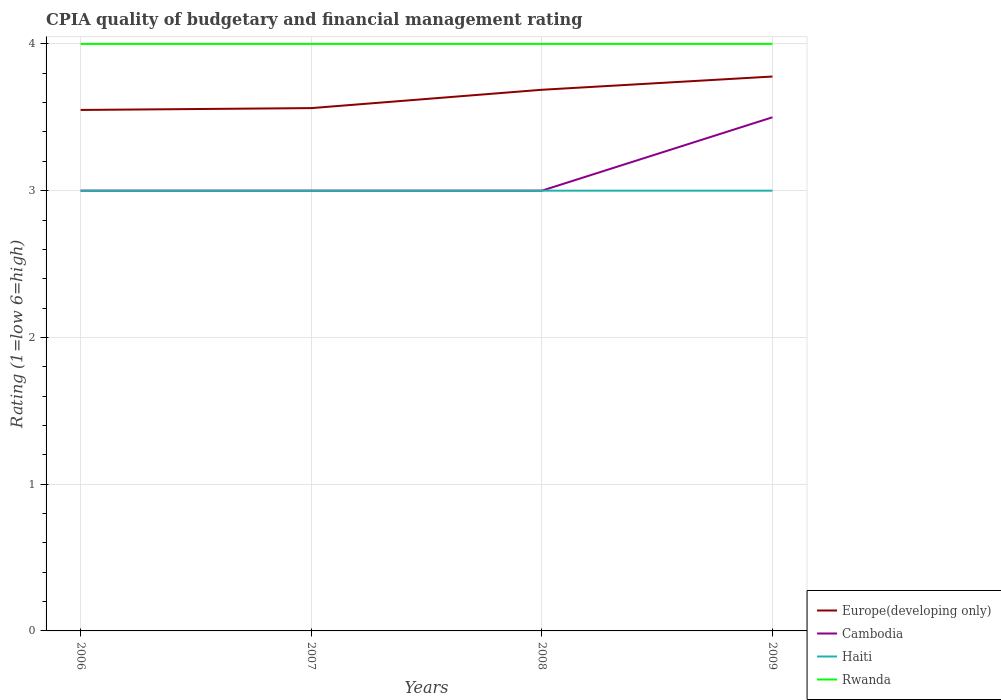Does the line corresponding to Rwanda intersect with the line corresponding to Cambodia?
Your answer should be compact. No. Is the number of lines equal to the number of legend labels?
Your answer should be compact. Yes. What is the total CPIA rating in Europe(developing only) in the graph?
Your answer should be compact. -0.01. What is the difference between the highest and the second highest CPIA rating in Cambodia?
Give a very brief answer. 0.5. What is the difference between the highest and the lowest CPIA rating in Haiti?
Provide a short and direct response. 0. What is the difference between two consecutive major ticks on the Y-axis?
Make the answer very short. 1. Does the graph contain any zero values?
Make the answer very short. No. Does the graph contain grids?
Provide a short and direct response. Yes. How many legend labels are there?
Your answer should be very brief. 4. How are the legend labels stacked?
Provide a succinct answer. Vertical. What is the title of the graph?
Give a very brief answer. CPIA quality of budgetary and financial management rating. What is the label or title of the X-axis?
Provide a succinct answer. Years. What is the Rating (1=low 6=high) of Europe(developing only) in 2006?
Your answer should be very brief. 3.55. What is the Rating (1=low 6=high) of Haiti in 2006?
Your response must be concise. 3. What is the Rating (1=low 6=high) in Rwanda in 2006?
Offer a very short reply. 4. What is the Rating (1=low 6=high) of Europe(developing only) in 2007?
Make the answer very short. 3.56. What is the Rating (1=low 6=high) in Cambodia in 2007?
Your answer should be compact. 3. What is the Rating (1=low 6=high) in Haiti in 2007?
Your answer should be compact. 3. What is the Rating (1=low 6=high) of Europe(developing only) in 2008?
Offer a very short reply. 3.69. What is the Rating (1=low 6=high) in Europe(developing only) in 2009?
Give a very brief answer. 3.78. What is the Rating (1=low 6=high) of Cambodia in 2009?
Your answer should be compact. 3.5. What is the Rating (1=low 6=high) of Haiti in 2009?
Your response must be concise. 3. Across all years, what is the maximum Rating (1=low 6=high) in Europe(developing only)?
Offer a very short reply. 3.78. Across all years, what is the maximum Rating (1=low 6=high) of Rwanda?
Offer a terse response. 4. Across all years, what is the minimum Rating (1=low 6=high) in Europe(developing only)?
Provide a short and direct response. 3.55. What is the total Rating (1=low 6=high) of Europe(developing only) in the graph?
Your response must be concise. 14.58. What is the total Rating (1=low 6=high) of Cambodia in the graph?
Offer a terse response. 12.5. What is the total Rating (1=low 6=high) in Rwanda in the graph?
Keep it short and to the point. 16. What is the difference between the Rating (1=low 6=high) in Europe(developing only) in 2006 and that in 2007?
Your answer should be very brief. -0.01. What is the difference between the Rating (1=low 6=high) in Rwanda in 2006 and that in 2007?
Ensure brevity in your answer.  0. What is the difference between the Rating (1=low 6=high) of Europe(developing only) in 2006 and that in 2008?
Keep it short and to the point. -0.14. What is the difference between the Rating (1=low 6=high) in Cambodia in 2006 and that in 2008?
Offer a very short reply. 0. What is the difference between the Rating (1=low 6=high) of Rwanda in 2006 and that in 2008?
Provide a short and direct response. 0. What is the difference between the Rating (1=low 6=high) of Europe(developing only) in 2006 and that in 2009?
Keep it short and to the point. -0.23. What is the difference between the Rating (1=low 6=high) in Rwanda in 2006 and that in 2009?
Your answer should be compact. 0. What is the difference between the Rating (1=low 6=high) of Europe(developing only) in 2007 and that in 2008?
Make the answer very short. -0.12. What is the difference between the Rating (1=low 6=high) of Haiti in 2007 and that in 2008?
Provide a succinct answer. 0. What is the difference between the Rating (1=low 6=high) of Rwanda in 2007 and that in 2008?
Your response must be concise. 0. What is the difference between the Rating (1=low 6=high) in Europe(developing only) in 2007 and that in 2009?
Offer a terse response. -0.22. What is the difference between the Rating (1=low 6=high) of Haiti in 2007 and that in 2009?
Ensure brevity in your answer.  0. What is the difference between the Rating (1=low 6=high) in Europe(developing only) in 2008 and that in 2009?
Offer a terse response. -0.09. What is the difference between the Rating (1=low 6=high) in Cambodia in 2008 and that in 2009?
Your answer should be compact. -0.5. What is the difference between the Rating (1=low 6=high) in Rwanda in 2008 and that in 2009?
Your response must be concise. 0. What is the difference between the Rating (1=low 6=high) of Europe(developing only) in 2006 and the Rating (1=low 6=high) of Cambodia in 2007?
Your response must be concise. 0.55. What is the difference between the Rating (1=low 6=high) of Europe(developing only) in 2006 and the Rating (1=low 6=high) of Haiti in 2007?
Give a very brief answer. 0.55. What is the difference between the Rating (1=low 6=high) of Europe(developing only) in 2006 and the Rating (1=low 6=high) of Rwanda in 2007?
Your answer should be very brief. -0.45. What is the difference between the Rating (1=low 6=high) in Cambodia in 2006 and the Rating (1=low 6=high) in Haiti in 2007?
Your answer should be compact. 0. What is the difference between the Rating (1=low 6=high) in Haiti in 2006 and the Rating (1=low 6=high) in Rwanda in 2007?
Your answer should be compact. -1. What is the difference between the Rating (1=low 6=high) of Europe(developing only) in 2006 and the Rating (1=low 6=high) of Cambodia in 2008?
Give a very brief answer. 0.55. What is the difference between the Rating (1=low 6=high) of Europe(developing only) in 2006 and the Rating (1=low 6=high) of Haiti in 2008?
Your response must be concise. 0.55. What is the difference between the Rating (1=low 6=high) of Europe(developing only) in 2006 and the Rating (1=low 6=high) of Rwanda in 2008?
Your answer should be very brief. -0.45. What is the difference between the Rating (1=low 6=high) of Cambodia in 2006 and the Rating (1=low 6=high) of Rwanda in 2008?
Your answer should be compact. -1. What is the difference between the Rating (1=low 6=high) in Haiti in 2006 and the Rating (1=low 6=high) in Rwanda in 2008?
Your answer should be very brief. -1. What is the difference between the Rating (1=low 6=high) of Europe(developing only) in 2006 and the Rating (1=low 6=high) of Haiti in 2009?
Your response must be concise. 0.55. What is the difference between the Rating (1=low 6=high) of Europe(developing only) in 2006 and the Rating (1=low 6=high) of Rwanda in 2009?
Provide a succinct answer. -0.45. What is the difference between the Rating (1=low 6=high) in Cambodia in 2006 and the Rating (1=low 6=high) in Haiti in 2009?
Offer a terse response. 0. What is the difference between the Rating (1=low 6=high) in Cambodia in 2006 and the Rating (1=low 6=high) in Rwanda in 2009?
Provide a short and direct response. -1. What is the difference between the Rating (1=low 6=high) in Haiti in 2006 and the Rating (1=low 6=high) in Rwanda in 2009?
Keep it short and to the point. -1. What is the difference between the Rating (1=low 6=high) in Europe(developing only) in 2007 and the Rating (1=low 6=high) in Cambodia in 2008?
Offer a very short reply. 0.56. What is the difference between the Rating (1=low 6=high) of Europe(developing only) in 2007 and the Rating (1=low 6=high) of Haiti in 2008?
Provide a short and direct response. 0.56. What is the difference between the Rating (1=low 6=high) in Europe(developing only) in 2007 and the Rating (1=low 6=high) in Rwanda in 2008?
Offer a terse response. -0.44. What is the difference between the Rating (1=low 6=high) in Cambodia in 2007 and the Rating (1=low 6=high) in Haiti in 2008?
Provide a short and direct response. 0. What is the difference between the Rating (1=low 6=high) in Cambodia in 2007 and the Rating (1=low 6=high) in Rwanda in 2008?
Provide a succinct answer. -1. What is the difference between the Rating (1=low 6=high) of Europe(developing only) in 2007 and the Rating (1=low 6=high) of Cambodia in 2009?
Give a very brief answer. 0.06. What is the difference between the Rating (1=low 6=high) in Europe(developing only) in 2007 and the Rating (1=low 6=high) in Haiti in 2009?
Provide a succinct answer. 0.56. What is the difference between the Rating (1=low 6=high) of Europe(developing only) in 2007 and the Rating (1=low 6=high) of Rwanda in 2009?
Ensure brevity in your answer.  -0.44. What is the difference between the Rating (1=low 6=high) of Cambodia in 2007 and the Rating (1=low 6=high) of Rwanda in 2009?
Make the answer very short. -1. What is the difference between the Rating (1=low 6=high) of Haiti in 2007 and the Rating (1=low 6=high) of Rwanda in 2009?
Offer a very short reply. -1. What is the difference between the Rating (1=low 6=high) of Europe(developing only) in 2008 and the Rating (1=low 6=high) of Cambodia in 2009?
Your answer should be compact. 0.19. What is the difference between the Rating (1=low 6=high) of Europe(developing only) in 2008 and the Rating (1=low 6=high) of Haiti in 2009?
Make the answer very short. 0.69. What is the difference between the Rating (1=low 6=high) of Europe(developing only) in 2008 and the Rating (1=low 6=high) of Rwanda in 2009?
Provide a short and direct response. -0.31. What is the average Rating (1=low 6=high) of Europe(developing only) per year?
Your response must be concise. 3.64. What is the average Rating (1=low 6=high) of Cambodia per year?
Give a very brief answer. 3.12. What is the average Rating (1=low 6=high) in Haiti per year?
Provide a short and direct response. 3. What is the average Rating (1=low 6=high) of Rwanda per year?
Provide a short and direct response. 4. In the year 2006, what is the difference between the Rating (1=low 6=high) of Europe(developing only) and Rating (1=low 6=high) of Cambodia?
Give a very brief answer. 0.55. In the year 2006, what is the difference between the Rating (1=low 6=high) in Europe(developing only) and Rating (1=low 6=high) in Haiti?
Offer a very short reply. 0.55. In the year 2006, what is the difference between the Rating (1=low 6=high) in Europe(developing only) and Rating (1=low 6=high) in Rwanda?
Offer a very short reply. -0.45. In the year 2007, what is the difference between the Rating (1=low 6=high) of Europe(developing only) and Rating (1=low 6=high) of Cambodia?
Provide a short and direct response. 0.56. In the year 2007, what is the difference between the Rating (1=low 6=high) of Europe(developing only) and Rating (1=low 6=high) of Haiti?
Make the answer very short. 0.56. In the year 2007, what is the difference between the Rating (1=low 6=high) of Europe(developing only) and Rating (1=low 6=high) of Rwanda?
Offer a very short reply. -0.44. In the year 2007, what is the difference between the Rating (1=low 6=high) in Cambodia and Rating (1=low 6=high) in Haiti?
Ensure brevity in your answer.  0. In the year 2007, what is the difference between the Rating (1=low 6=high) in Cambodia and Rating (1=low 6=high) in Rwanda?
Your answer should be very brief. -1. In the year 2007, what is the difference between the Rating (1=low 6=high) in Haiti and Rating (1=low 6=high) in Rwanda?
Ensure brevity in your answer.  -1. In the year 2008, what is the difference between the Rating (1=low 6=high) of Europe(developing only) and Rating (1=low 6=high) of Cambodia?
Keep it short and to the point. 0.69. In the year 2008, what is the difference between the Rating (1=low 6=high) of Europe(developing only) and Rating (1=low 6=high) of Haiti?
Your response must be concise. 0.69. In the year 2008, what is the difference between the Rating (1=low 6=high) of Europe(developing only) and Rating (1=low 6=high) of Rwanda?
Offer a terse response. -0.31. In the year 2009, what is the difference between the Rating (1=low 6=high) in Europe(developing only) and Rating (1=low 6=high) in Cambodia?
Provide a short and direct response. 0.28. In the year 2009, what is the difference between the Rating (1=low 6=high) in Europe(developing only) and Rating (1=low 6=high) in Rwanda?
Your answer should be very brief. -0.22. What is the ratio of the Rating (1=low 6=high) in Europe(developing only) in 2006 to that in 2008?
Offer a terse response. 0.96. What is the ratio of the Rating (1=low 6=high) of Cambodia in 2006 to that in 2008?
Offer a terse response. 1. What is the ratio of the Rating (1=low 6=high) of Haiti in 2006 to that in 2008?
Offer a very short reply. 1. What is the ratio of the Rating (1=low 6=high) of Europe(developing only) in 2006 to that in 2009?
Provide a succinct answer. 0.94. What is the ratio of the Rating (1=low 6=high) in Cambodia in 2006 to that in 2009?
Keep it short and to the point. 0.86. What is the ratio of the Rating (1=low 6=high) in Haiti in 2006 to that in 2009?
Make the answer very short. 1. What is the ratio of the Rating (1=low 6=high) in Europe(developing only) in 2007 to that in 2008?
Your answer should be very brief. 0.97. What is the ratio of the Rating (1=low 6=high) of Haiti in 2007 to that in 2008?
Offer a terse response. 1. What is the ratio of the Rating (1=low 6=high) of Europe(developing only) in 2007 to that in 2009?
Your answer should be compact. 0.94. What is the ratio of the Rating (1=low 6=high) of Europe(developing only) in 2008 to that in 2009?
Provide a succinct answer. 0.98. What is the difference between the highest and the second highest Rating (1=low 6=high) in Europe(developing only)?
Ensure brevity in your answer.  0.09. What is the difference between the highest and the lowest Rating (1=low 6=high) in Europe(developing only)?
Make the answer very short. 0.23. 